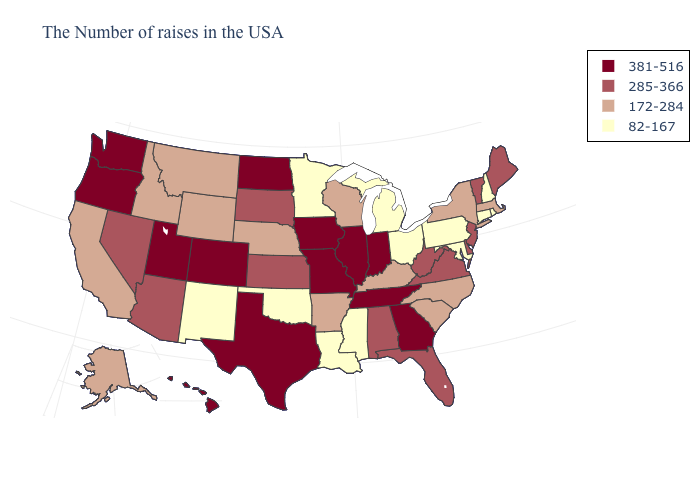Among the states that border Oklahoma , does New Mexico have the lowest value?
Give a very brief answer. Yes. Name the states that have a value in the range 172-284?
Answer briefly. Massachusetts, New York, North Carolina, South Carolina, Kentucky, Wisconsin, Arkansas, Nebraska, Wyoming, Montana, Idaho, California, Alaska. Name the states that have a value in the range 381-516?
Be succinct. Georgia, Indiana, Tennessee, Illinois, Missouri, Iowa, Texas, North Dakota, Colorado, Utah, Washington, Oregon, Hawaii. Among the states that border South Carolina , does North Carolina have the highest value?
Write a very short answer. No. What is the highest value in the USA?
Be succinct. 381-516. Name the states that have a value in the range 285-366?
Quick response, please. Maine, Vermont, New Jersey, Delaware, Virginia, West Virginia, Florida, Alabama, Kansas, South Dakota, Arizona, Nevada. What is the value of Vermont?
Concise answer only. 285-366. Name the states that have a value in the range 172-284?
Short answer required. Massachusetts, New York, North Carolina, South Carolina, Kentucky, Wisconsin, Arkansas, Nebraska, Wyoming, Montana, Idaho, California, Alaska. What is the value of Montana?
Quick response, please. 172-284. What is the highest value in the West ?
Write a very short answer. 381-516. What is the value of West Virginia?
Short answer required. 285-366. Among the states that border Georgia , does Tennessee have the highest value?
Concise answer only. Yes. Does Alaska have a lower value than Tennessee?
Write a very short answer. Yes. Name the states that have a value in the range 172-284?
Short answer required. Massachusetts, New York, North Carolina, South Carolina, Kentucky, Wisconsin, Arkansas, Nebraska, Wyoming, Montana, Idaho, California, Alaska. Does Maryland have the highest value in the USA?
Give a very brief answer. No. 